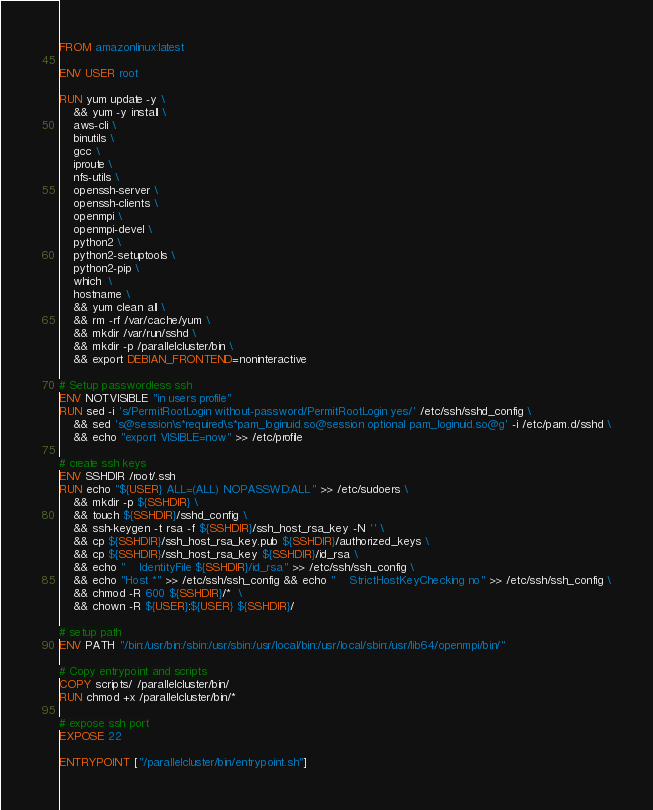Convert code to text. <code><loc_0><loc_0><loc_500><loc_500><_Dockerfile_>FROM amazonlinux:latest

ENV USER root

RUN yum update -y \
    && yum -y install \
    aws-cli \
    binutils \
    gcc \
    iproute \
    nfs-utils \
    openssh-server \
    openssh-clients \
    openmpi \
    openmpi-devel \
    python2 \
    python2-setuptools \
    python2-pip \
    which  \
    hostname \
    && yum clean all \
    && rm -rf /var/cache/yum \
    && mkdir /var/run/sshd \
    && mkdir -p /parallelcluster/bin \
    && export DEBIAN_FRONTEND=noninteractive

# Setup passwordless ssh
ENV NOTVISIBLE "in users profile"
RUN sed -i 's/PermitRootLogin without-password/PermitRootLogin yes/' /etc/ssh/sshd_config \
    && sed 's@session\s*required\s*pam_loginuid.so@session optional pam_loginuid.so@g' -i /etc/pam.d/sshd \
    && echo "export VISIBLE=now" >> /etc/profile

# create ssh keys
ENV SSHDIR /root/.ssh
RUN echo "${USER} ALL=(ALL) NOPASSWD:ALL" >> /etc/sudoers \
    && mkdir -p ${SSHDIR} \
    && touch ${SSHDIR}/sshd_config \
    && ssh-keygen -t rsa -f ${SSHDIR}/ssh_host_rsa_key -N '' \
    && cp ${SSHDIR}/ssh_host_rsa_key.pub ${SSHDIR}/authorized_keys \
    && cp ${SSHDIR}/ssh_host_rsa_key ${SSHDIR}/id_rsa \
    && echo "    IdentityFile ${SSHDIR}/id_rsa" >> /etc/ssh/ssh_config \
    && echo "Host *" >> /etc/ssh/ssh_config && echo "    StrictHostKeyChecking no" >> /etc/ssh/ssh_config \
    && chmod -R 600 ${SSHDIR}/*  \
    && chown -R ${USER}:${USER} ${SSHDIR}/

# setup path
ENV PATH "/bin:/usr/bin:/sbin:/usr/sbin:/usr/local/bin:/usr/local/sbin:/usr/lib64/openmpi/bin/"

# Copy entrypoint and scripts
COPY scripts/ /parallelcluster/bin/
RUN chmod +x /parallelcluster/bin/*

# expose ssh port
EXPOSE 22

ENTRYPOINT ["/parallelcluster/bin/entrypoint.sh"]
</code> 